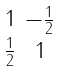Convert formula to latex. <formula><loc_0><loc_0><loc_500><loc_500>\begin{smallmatrix} 1 & - \frac { 1 } { 2 } \\ \frac { 1 } { 2 } & 1 \end{smallmatrix}</formula> 